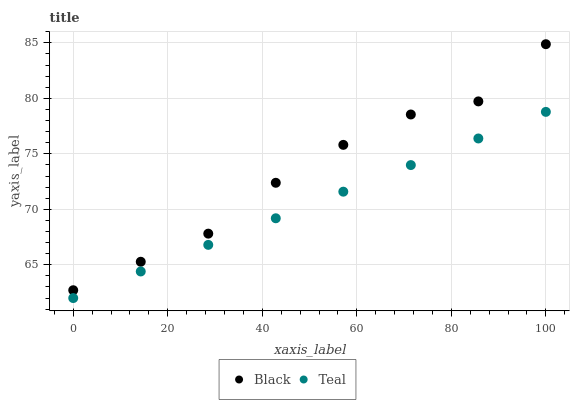Does Teal have the minimum area under the curve?
Answer yes or no. Yes. Does Black have the maximum area under the curve?
Answer yes or no. Yes. Does Teal have the maximum area under the curve?
Answer yes or no. No. Is Teal the smoothest?
Answer yes or no. Yes. Is Black the roughest?
Answer yes or no. Yes. Is Teal the roughest?
Answer yes or no. No. Does Teal have the lowest value?
Answer yes or no. Yes. Does Black have the highest value?
Answer yes or no. Yes. Does Teal have the highest value?
Answer yes or no. No. Is Teal less than Black?
Answer yes or no. Yes. Is Black greater than Teal?
Answer yes or no. Yes. Does Teal intersect Black?
Answer yes or no. No. 